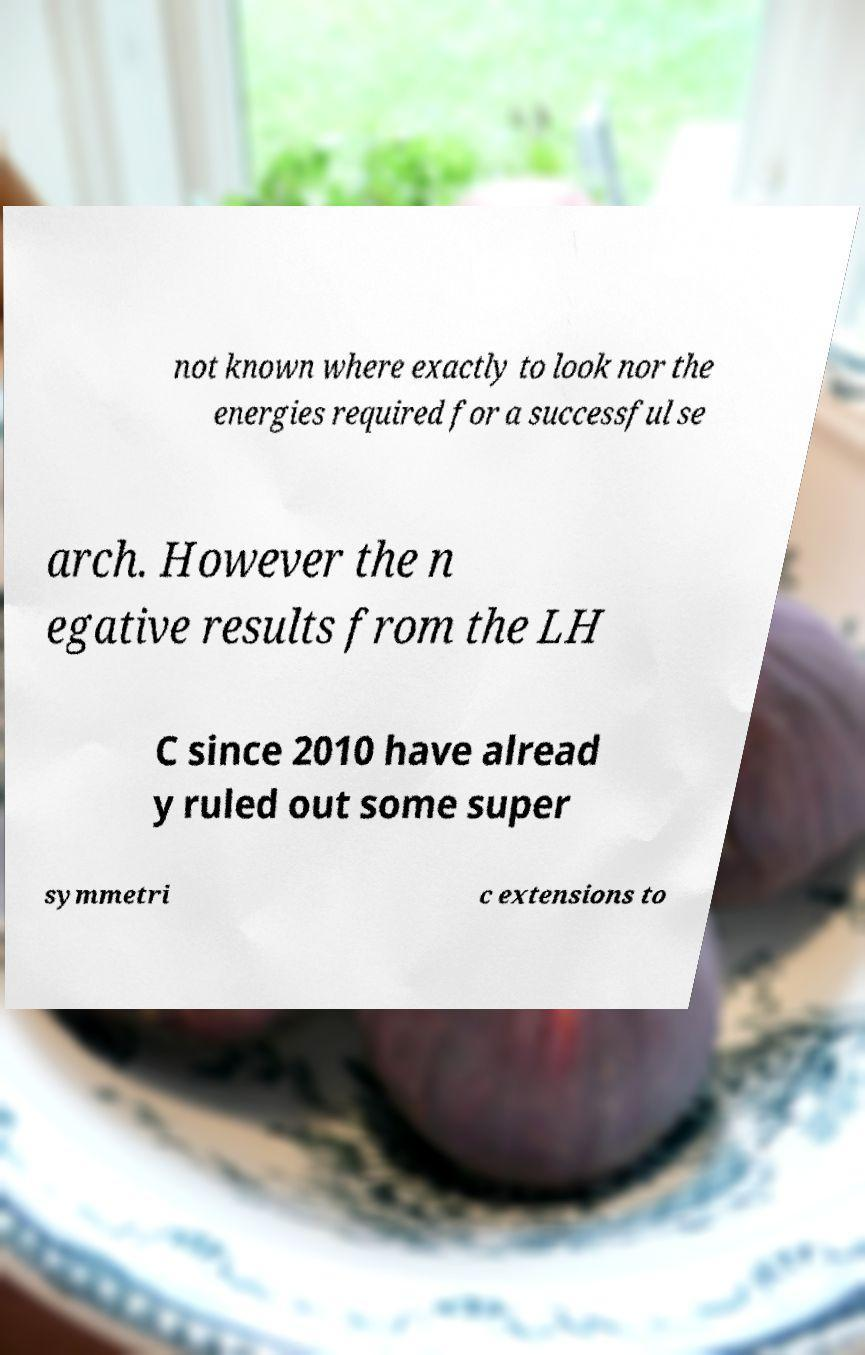Could you extract and type out the text from this image? not known where exactly to look nor the energies required for a successful se arch. However the n egative results from the LH C since 2010 have alread y ruled out some super symmetri c extensions to 